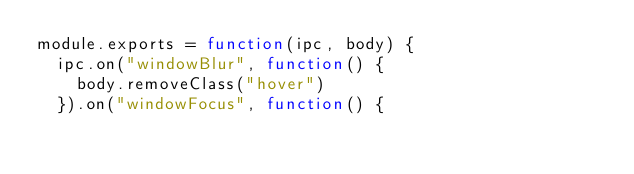<code> <loc_0><loc_0><loc_500><loc_500><_JavaScript_>module.exports = function(ipc, body) {
  ipc.on("windowBlur", function() {
    body.removeClass("hover")
  }).on("windowFocus", function() {</code> 